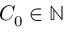<formula> <loc_0><loc_0><loc_500><loc_500>C _ { 0 } \in \mathbb { N }</formula> 